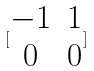Convert formula to latex. <formula><loc_0><loc_0><loc_500><loc_500>[ \begin{matrix} - 1 & 1 \\ 0 & 0 \end{matrix} ]</formula> 